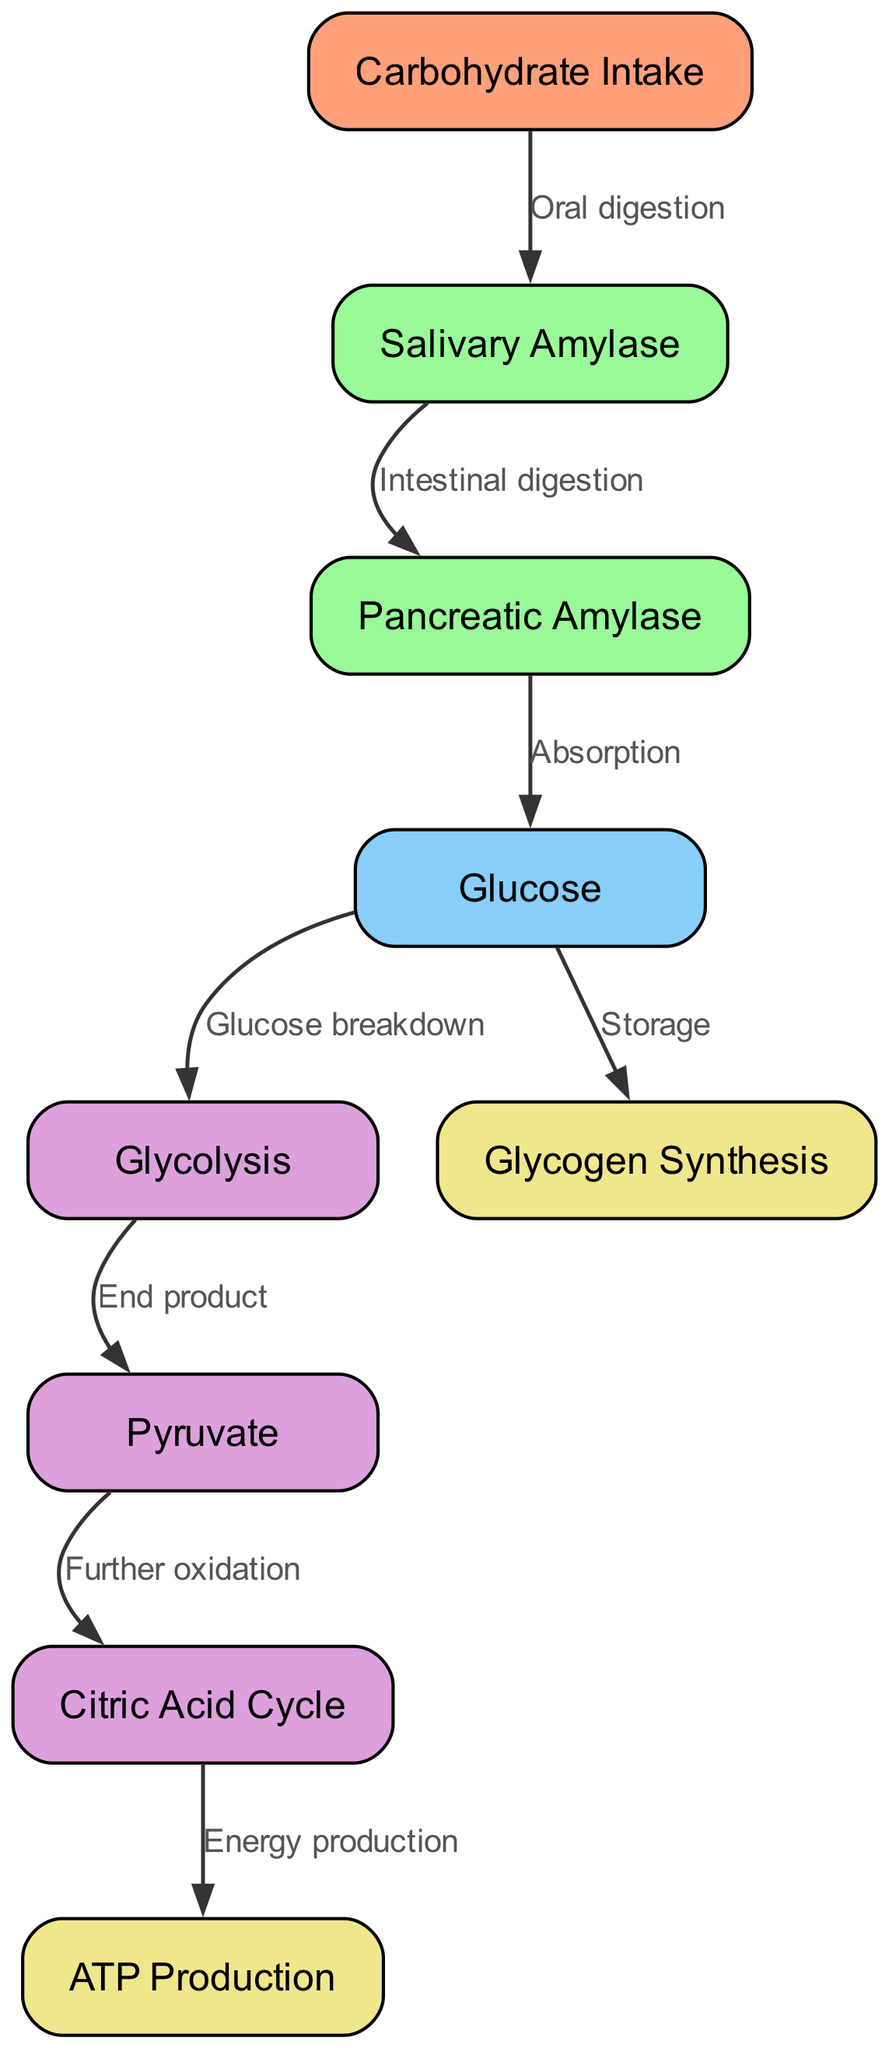What is the first step in carbohydrate metabolism? The first step is carbohydrate intake, as indicated by the node labeled "Carbohydrate Intake" which initiates the metabolic pathway.
Answer: Carbohydrate Intake How many nodes are present in the diagram? The diagram shows a total of nine nodes, which are depicted as distinct elements in the pathway of carbohydrate metabolism.
Answer: 9 What does salivary amylase do? Salivary amylase facilitates oral digestion, as illustrated by the edge connecting "Carbohydrate Intake" to "Salivary Amylase" with the label "Oral digestion".
Answer: Oral digestion What is formed after glycolysis? After glycolysis, pyruvate is formed, as noted by the edge leading from "Glycolysis" to "Pyruvate", labeled "End product".
Answer: Pyruvate What is the final product of the metabolic pathway according to the diagram? The final product is ATP production, as shown by the edge connecting "Citric Acid Cycle" to "ATP Production", labeled "Energy production".
Answer: ATP Production Which enzyme acts after salivary amylase? After salivary amylase, pancreatic amylase acts, as depicted by the edge leading from "Salivary Amylase" to "Pancreatic Amylase" with the label "Intestinal digestion".
Answer: Pancreatic Amylase What process occurs to glucose besides its breakdown? Besides its breakdown, glucose can also undergo glycogen synthesis, indicated by the parallel edge leaving "Glucose" towards "Glycogen Synthesis" with the label "Storage".
Answer: Glycogen Synthesis How does pyruvate contribute to energy production? Pyruvate contributes to energy production by entering the citric acid cycle for further oxidation, leading to ATP production as illustrated by the edge connecting "Pyruvate" to "Citric Acid Cycle".
Answer: Citric Acid Cycle During which stage does glucose get absorbed? Glucose is absorbed after the action of pancreatic amylase, as indicated by the edge that connects "Pancreatic Amylase" to "Glucose" with the label "Absorption".
Answer: Absorption 